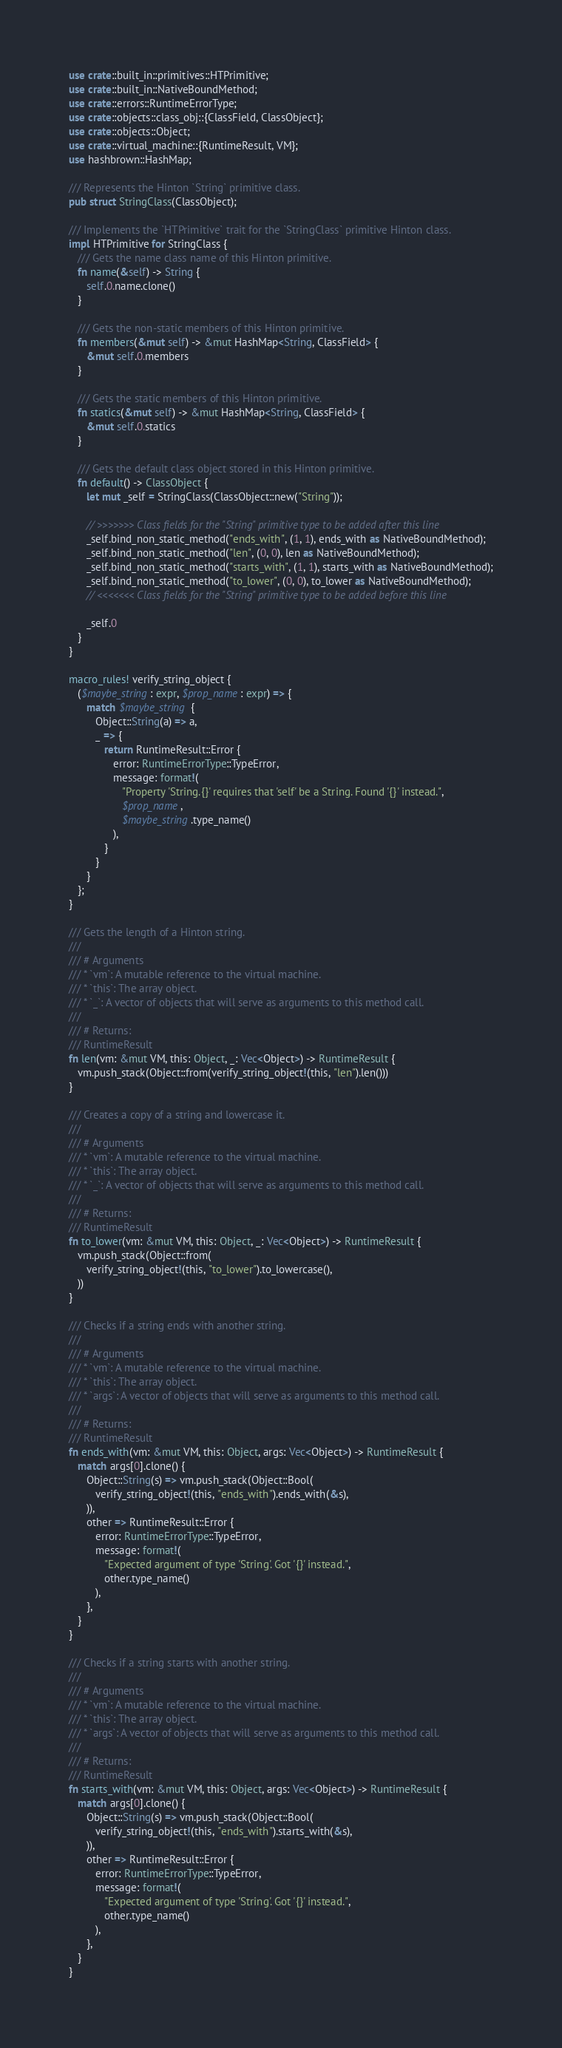<code> <loc_0><loc_0><loc_500><loc_500><_Rust_>use crate::built_in::primitives::HTPrimitive;
use crate::built_in::NativeBoundMethod;
use crate::errors::RuntimeErrorType;
use crate::objects::class_obj::{ClassField, ClassObject};
use crate::objects::Object;
use crate::virtual_machine::{RuntimeResult, VM};
use hashbrown::HashMap;

/// Represents the Hinton `String` primitive class.
pub struct StringClass(ClassObject);

/// Implements the `HTPrimitive` trait for the `StringClass` primitive Hinton class.
impl HTPrimitive for StringClass {
   /// Gets the name class name of this Hinton primitive.
   fn name(&self) -> String {
      self.0.name.clone()
   }

   /// Gets the non-static members of this Hinton primitive.
   fn members(&mut self) -> &mut HashMap<String, ClassField> {
      &mut self.0.members
   }

   /// Gets the static members of this Hinton primitive.
   fn statics(&mut self) -> &mut HashMap<String, ClassField> {
      &mut self.0.statics
   }

   /// Gets the default class object stored in this Hinton primitive.
   fn default() -> ClassObject {
      let mut _self = StringClass(ClassObject::new("String"));

      // >>>>>>> Class fields for the "String" primitive type to be added after this line
      _self.bind_non_static_method("ends_with", (1, 1), ends_with as NativeBoundMethod);
      _self.bind_non_static_method("len", (0, 0), len as NativeBoundMethod);
      _self.bind_non_static_method("starts_with", (1, 1), starts_with as NativeBoundMethod);
      _self.bind_non_static_method("to_lower", (0, 0), to_lower as NativeBoundMethod);
      // <<<<<<< Class fields for the "String" primitive type to be added before this line

      _self.0
   }
}

macro_rules! verify_string_object {
   ($maybe_string: expr, $prop_name: expr) => {
      match $maybe_string {
         Object::String(a) => a,
         _ => {
            return RuntimeResult::Error {
               error: RuntimeErrorType::TypeError,
               message: format!(
                  "Property 'String.{}' requires that 'self' be a String. Found '{}' instead.",
                  $prop_name,
                  $maybe_string.type_name()
               ),
            }
         }
      }
   };
}

/// Gets the length of a Hinton string.
///
/// # Arguments
/// * `vm`: A mutable reference to the virtual machine.
/// * `this`: The array object.
/// * `_`: A vector of objects that will serve as arguments to this method call.
///
/// # Returns:
/// RuntimeResult
fn len(vm: &mut VM, this: Object, _: Vec<Object>) -> RuntimeResult {
   vm.push_stack(Object::from(verify_string_object!(this, "len").len()))
}

/// Creates a copy of a string and lowercase it.
///
/// # Arguments
/// * `vm`: A mutable reference to the virtual machine.
/// * `this`: The array object.
/// * `_`: A vector of objects that will serve as arguments to this method call.
///
/// # Returns:
/// RuntimeResult
fn to_lower(vm: &mut VM, this: Object, _: Vec<Object>) -> RuntimeResult {
   vm.push_stack(Object::from(
      verify_string_object!(this, "to_lower").to_lowercase(),
   ))
}

/// Checks if a string ends with another string.
///
/// # Arguments
/// * `vm`: A mutable reference to the virtual machine.
/// * `this`: The array object.
/// * `args`: A vector of objects that will serve as arguments to this method call.
///
/// # Returns:
/// RuntimeResult
fn ends_with(vm: &mut VM, this: Object, args: Vec<Object>) -> RuntimeResult {
   match args[0].clone() {
      Object::String(s) => vm.push_stack(Object::Bool(
         verify_string_object!(this, "ends_with").ends_with(&s),
      )),
      other => RuntimeResult::Error {
         error: RuntimeErrorType::TypeError,
         message: format!(
            "Expected argument of type 'String'. Got '{}' instead.",
            other.type_name()
         ),
      },
   }
}

/// Checks if a string starts with another string.
///
/// # Arguments
/// * `vm`: A mutable reference to the virtual machine.
/// * `this`: The array object.
/// * `args`: A vector of objects that will serve as arguments to this method call.
///
/// # Returns:
/// RuntimeResult
fn starts_with(vm: &mut VM, this: Object, args: Vec<Object>) -> RuntimeResult {
   match args[0].clone() {
      Object::String(s) => vm.push_stack(Object::Bool(
         verify_string_object!(this, "ends_with").starts_with(&s),
      )),
      other => RuntimeResult::Error {
         error: RuntimeErrorType::TypeError,
         message: format!(
            "Expected argument of type 'String'. Got '{}' instead.",
            other.type_name()
         ),
      },
   }
}
</code> 